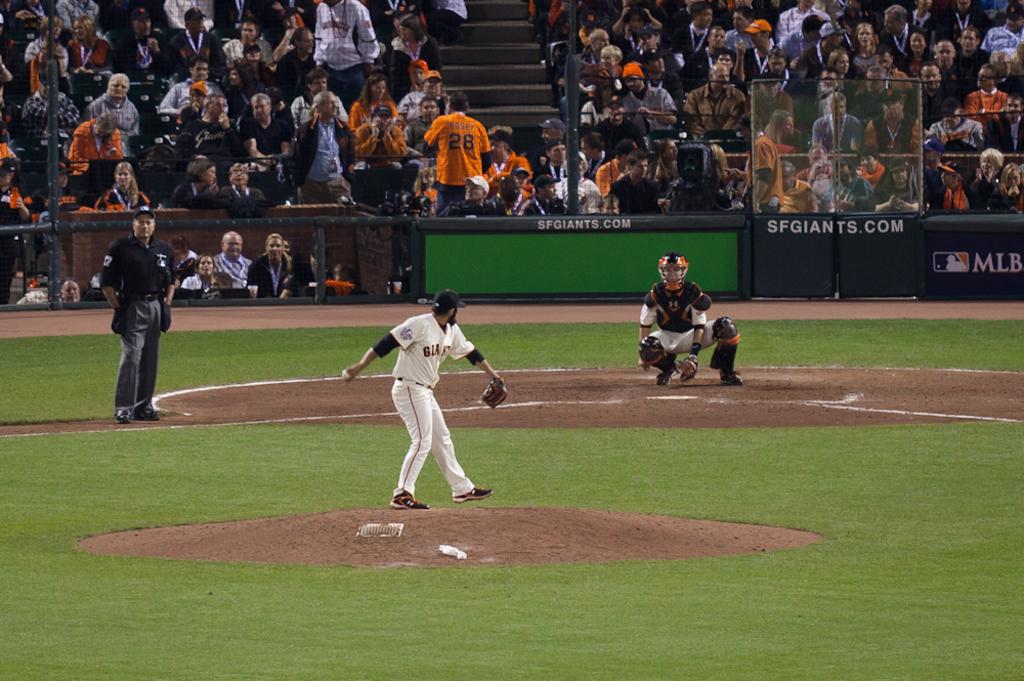<image>
Offer a succinct explanation of the picture presented. a player playing baseball with a Giants jersey 